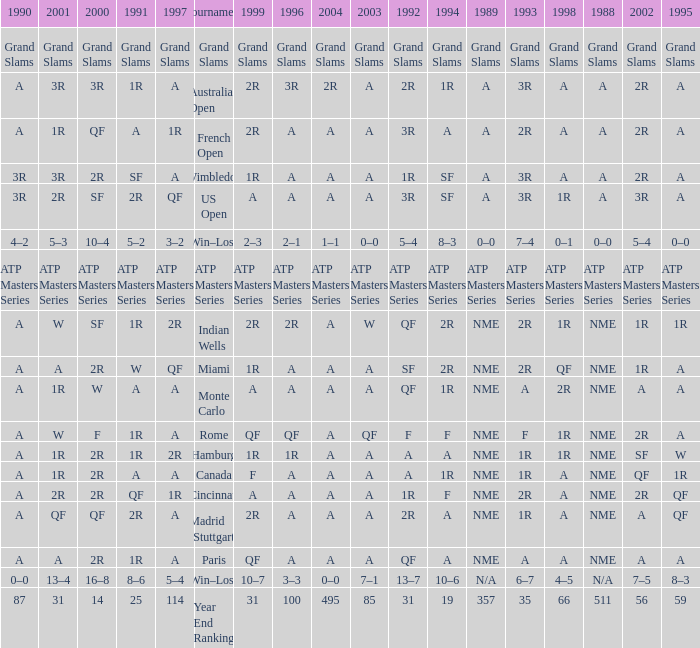Can you parse all the data within this table? {'header': ['1990', '2001', '2000', '1991', '1997', 'Tournament', '1999', '1996', '2004', '2003', '1992', '1994', '1989', '1993', '1998', '1988', '2002', '1995'], 'rows': [['Grand Slams', 'Grand Slams', 'Grand Slams', 'Grand Slams', 'Grand Slams', 'Grand Slams', 'Grand Slams', 'Grand Slams', 'Grand Slams', 'Grand Slams', 'Grand Slams', 'Grand Slams', 'Grand Slams', 'Grand Slams', 'Grand Slams', 'Grand Slams', 'Grand Slams', 'Grand Slams'], ['A', '3R', '3R', '1R', 'A', 'Australian Open', '2R', '3R', '2R', 'A', '2R', '1R', 'A', '3R', 'A', 'A', '2R', 'A'], ['A', '1R', 'QF', 'A', '1R', 'French Open', '2R', 'A', 'A', 'A', '3R', 'A', 'A', '2R', 'A', 'A', '2R', 'A'], ['3R', '3R', '2R', 'SF', 'A', 'Wimbledon', '1R', 'A', 'A', 'A', '1R', 'SF', 'A', '3R', 'A', 'A', '2R', 'A'], ['3R', '2R', 'SF', '2R', 'QF', 'US Open', 'A', 'A', 'A', 'A', '3R', 'SF', 'A', '3R', '1R', 'A', '3R', 'A'], ['4–2', '5–3', '10–4', '5–2', '3–2', 'Win–Loss', '2–3', '2–1', '1–1', '0–0', '5–4', '8–3', '0–0', '7–4', '0–1', '0–0', '5–4', '0–0'], ['ATP Masters Series', 'ATP Masters Series', 'ATP Masters Series', 'ATP Masters Series', 'ATP Masters Series', 'ATP Masters Series', 'ATP Masters Series', 'ATP Masters Series', 'ATP Masters Series', 'ATP Masters Series', 'ATP Masters Series', 'ATP Masters Series', 'ATP Masters Series', 'ATP Masters Series', 'ATP Masters Series', 'ATP Masters Series', 'ATP Masters Series', 'ATP Masters Series'], ['A', 'W', 'SF', '1R', '2R', 'Indian Wells', '2R', '2R', 'A', 'W', 'QF', '2R', 'NME', '2R', '1R', 'NME', '1R', '1R'], ['A', 'A', '2R', 'W', 'QF', 'Miami', '1R', 'A', 'A', 'A', 'SF', '2R', 'NME', '2R', 'QF', 'NME', '1R', 'A'], ['A', '1R', 'W', 'A', 'A', 'Monte Carlo', 'A', 'A', 'A', 'A', 'QF', '1R', 'NME', 'A', '2R', 'NME', 'A', 'A'], ['A', 'W', 'F', '1R', 'A', 'Rome', 'QF', 'QF', 'A', 'QF', 'F', 'F', 'NME', 'F', '1R', 'NME', '2R', 'A'], ['A', '1R', '2R', '1R', '2R', 'Hamburg', '1R', '1R', 'A', 'A', 'A', 'A', 'NME', '1R', '1R', 'NME', 'SF', 'W'], ['A', '1R', '2R', 'A', 'A', 'Canada', 'F', 'A', 'A', 'A', 'A', '1R', 'NME', '1R', 'A', 'NME', 'QF', '1R'], ['A', '2R', '2R', 'QF', '1R', 'Cincinnati', 'A', 'A', 'A', 'A', '1R', 'F', 'NME', '2R', 'A', 'NME', '2R', 'QF'], ['A', 'QF', 'QF', '2R', 'A', 'Madrid (Stuttgart)', '2R', 'A', 'A', 'A', '2R', 'A', 'NME', '1R', 'A', 'NME', 'A', 'QF'], ['A', 'A', '2R', '1R', 'A', 'Paris', 'QF', 'A', 'A', 'A', 'QF', 'A', 'NME', 'A', 'A', 'NME', 'A', 'A'], ['0–0', '13–4', '16–8', '8–6', '5–4', 'Win–Loss', '10–7', '3–3', '0–0', '7–1', '13–7', '10–6', 'N/A', '6–7', '4–5', 'N/A', '7–5', '8–3'], ['87', '31', '14', '25', '114', 'Year End Ranking', '31', '100', '495', '85', '31', '19', '357', '35', '66', '511', '56', '59']]} What shows for 1988 when 1994 shows 10–6? N/A. 